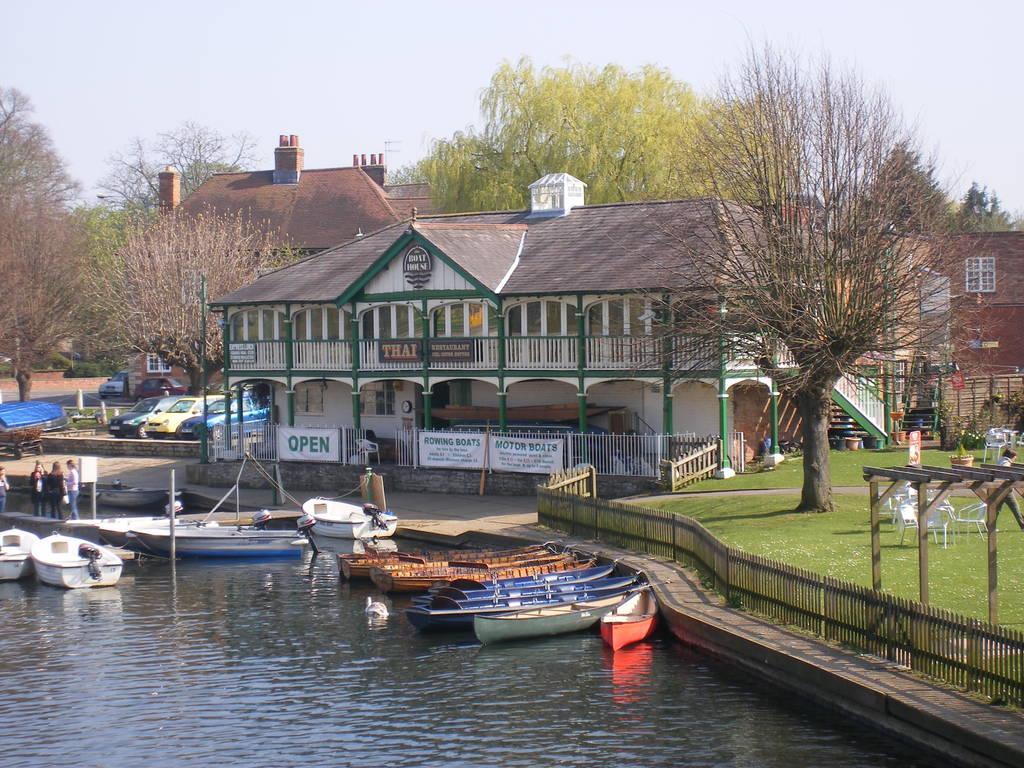Could you give a brief overview of what you see in this image? On the left side of the picture there is water, in the water there are boats. On the right side of the picture there are chairs, tables, tree, railing and grass. In the center of the picture there are buildings, trees, banners, vehicles and a tent. On the left there are people on the dock. It is sunny. 